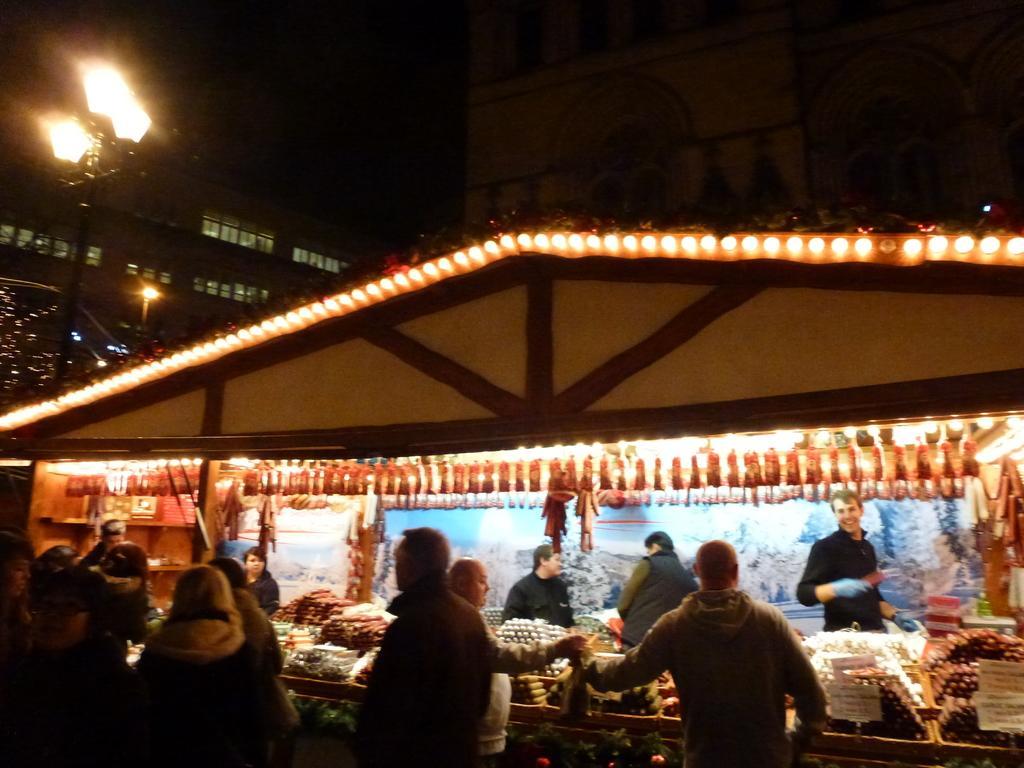How would you summarize this image in a sentence or two? In this image, we can see store, people, boards, lights and some objects. At the top of the image, there are buildings, walls, glass windows, lights, dark view and pole. 